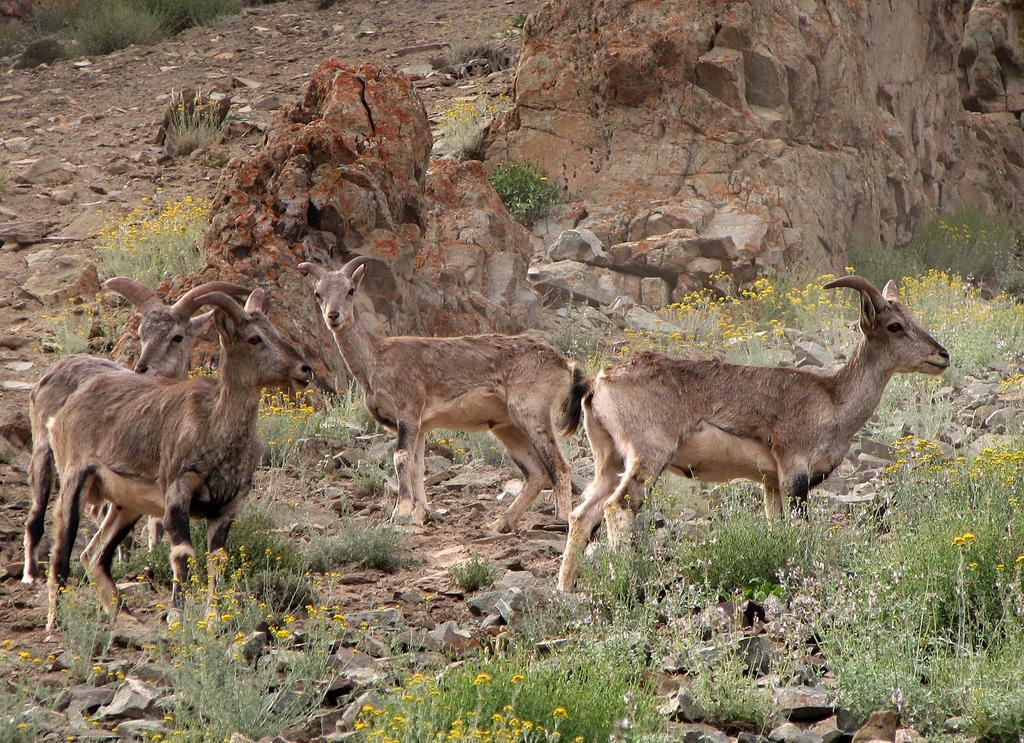How would you summarize this image in a sentence or two? In this image I can see animals. There is grass, there are rocks, stones, flowers and plants. 